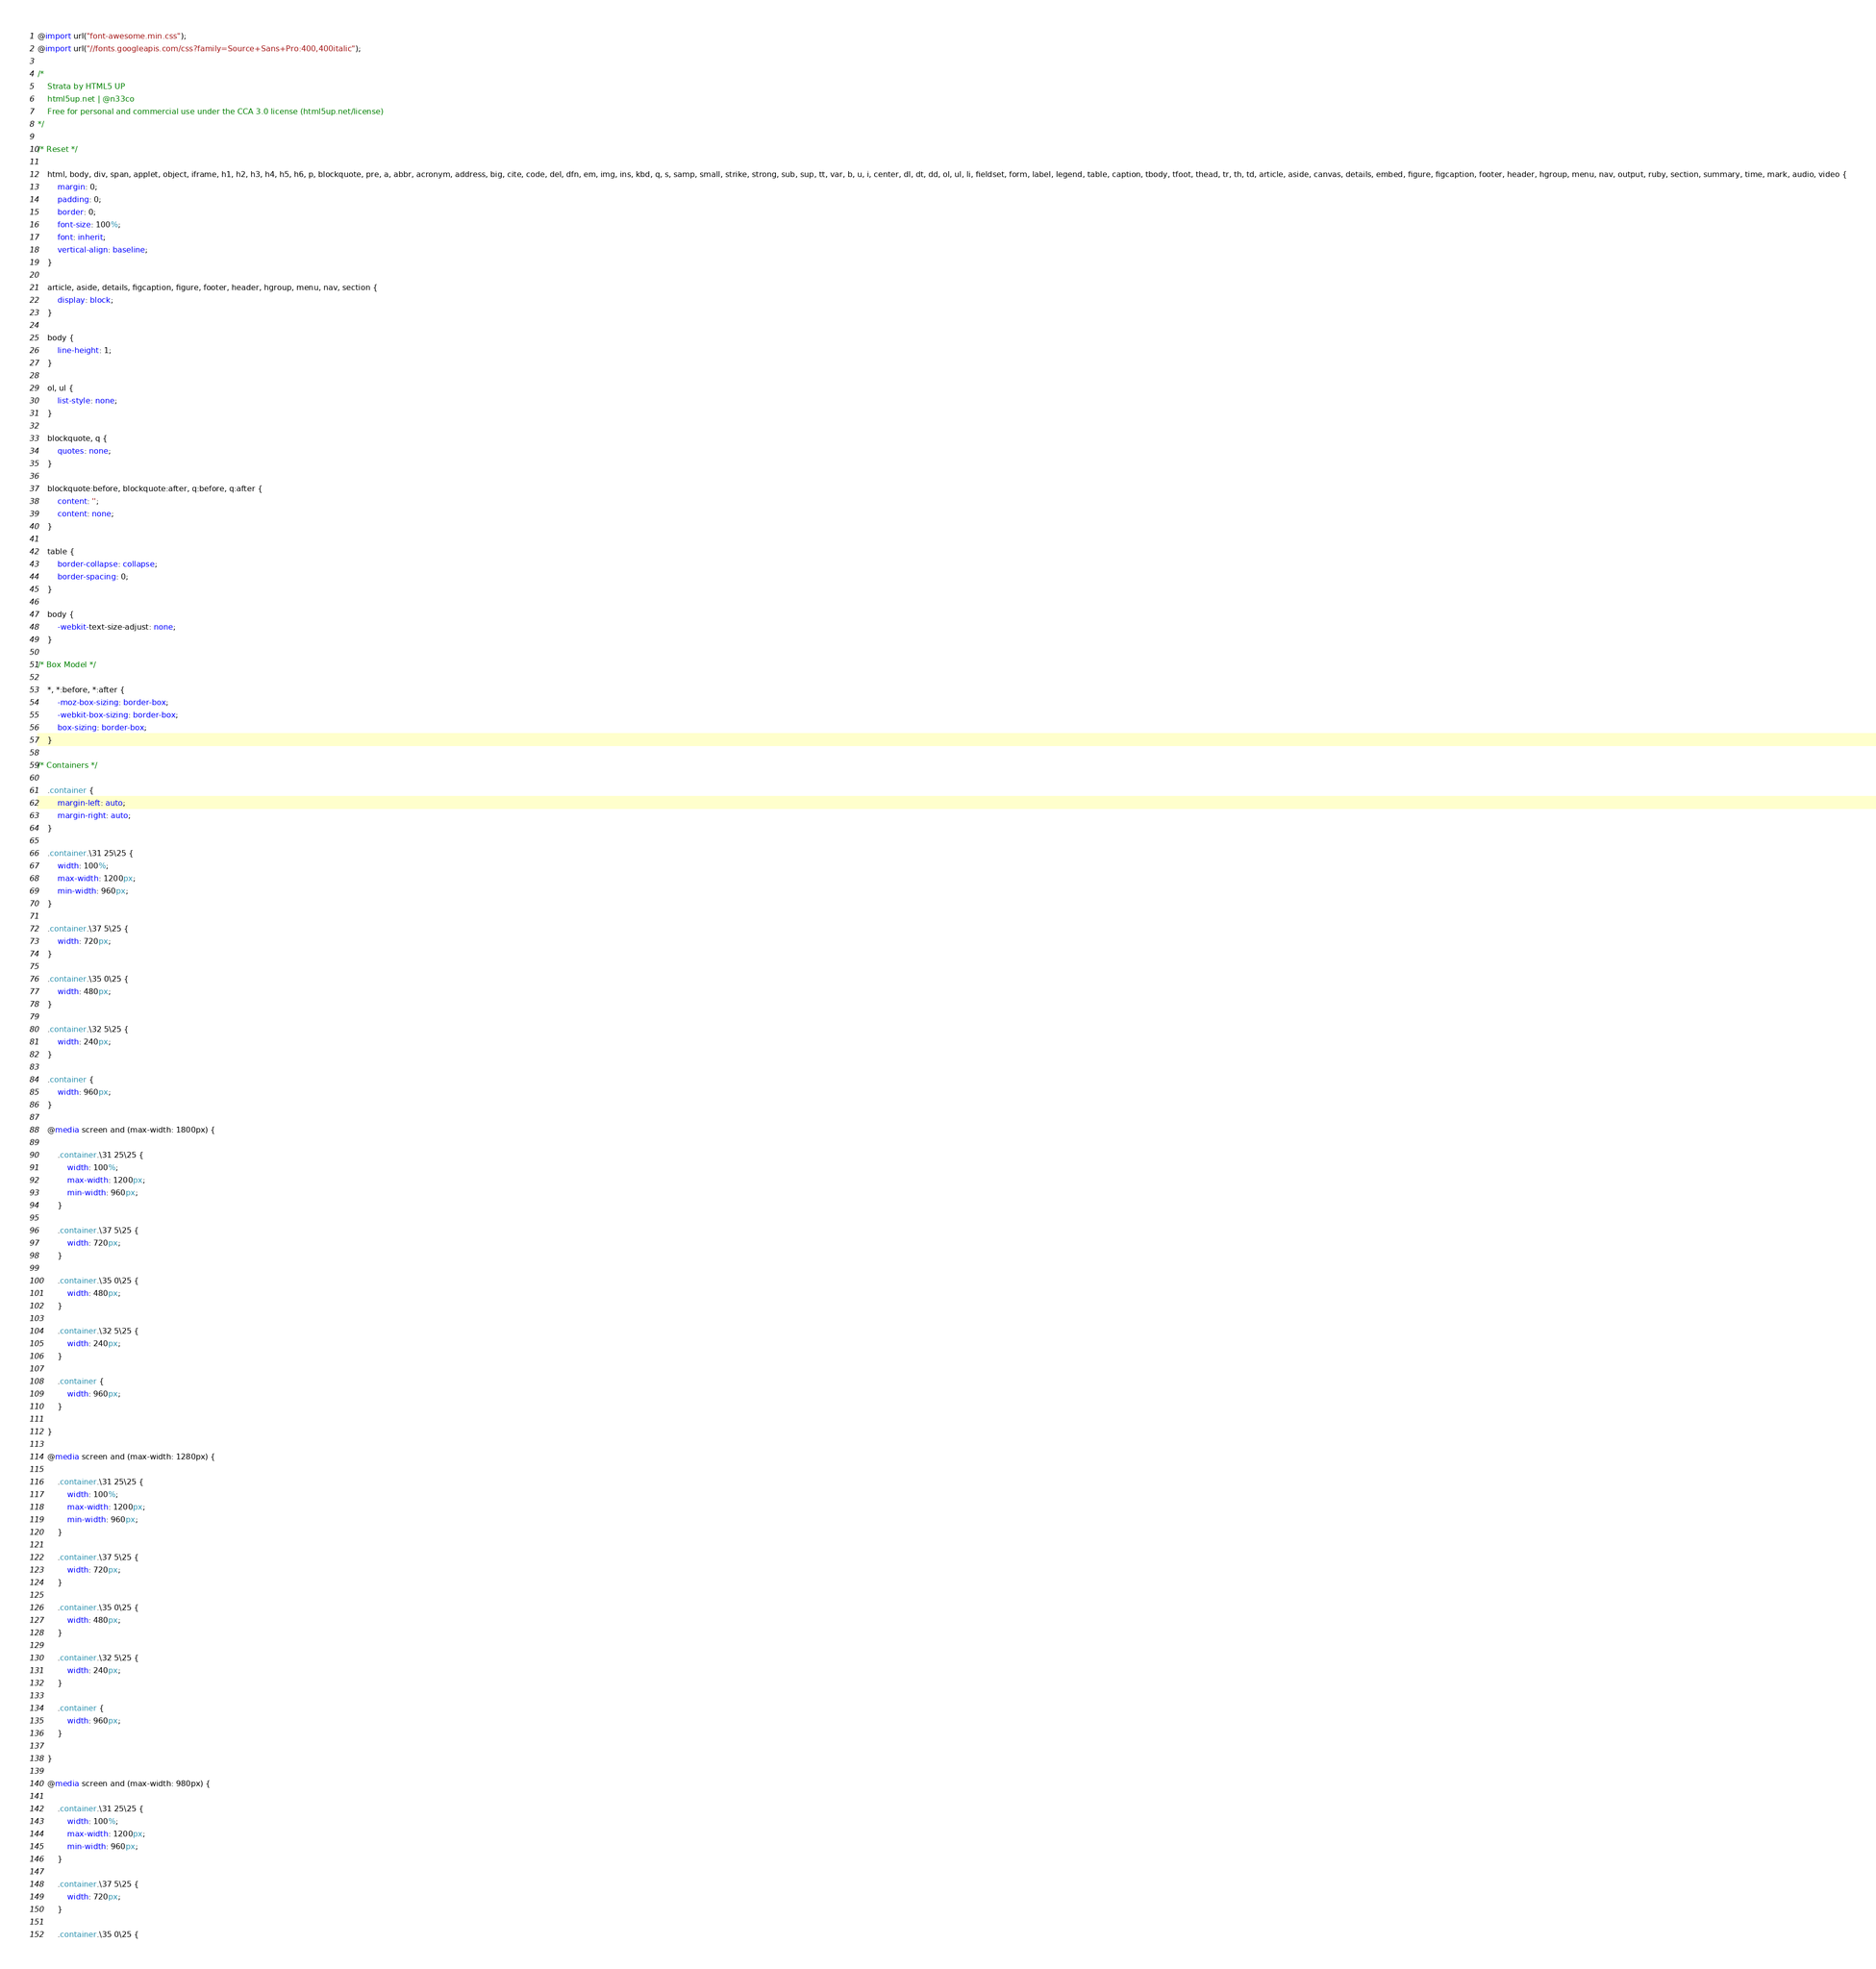<code> <loc_0><loc_0><loc_500><loc_500><_CSS_>@import url("font-awesome.min.css");
@import url("//fonts.googleapis.com/css?family=Source+Sans+Pro:400,400italic");

/*
	Strata by HTML5 UP
	html5up.net | @n33co
	Free for personal and commercial use under the CCA 3.0 license (html5up.net/license)
*/

/* Reset */

	html, body, div, span, applet, object, iframe, h1, h2, h3, h4, h5, h6, p, blockquote, pre, a, abbr, acronym, address, big, cite, code, del, dfn, em, img, ins, kbd, q, s, samp, small, strike, strong, sub, sup, tt, var, b, u, i, center, dl, dt, dd, ol, ul, li, fieldset, form, label, legend, table, caption, tbody, tfoot, thead, tr, th, td, article, aside, canvas, details, embed, figure, figcaption, footer, header, hgroup, menu, nav, output, ruby, section, summary, time, mark, audio, video {
		margin: 0;
		padding: 0;
		border: 0;
		font-size: 100%;
		font: inherit;
		vertical-align: baseline;
	}

	article, aside, details, figcaption, figure, footer, header, hgroup, menu, nav, section {
		display: block;
	}

	body {
		line-height: 1;
	}

	ol, ul {
		list-style: none;
	}

	blockquote, q {
		quotes: none;
	}

	blockquote:before, blockquote:after, q:before, q:after {
		content: '';
		content: none;
	}

	table {
		border-collapse: collapse;
		border-spacing: 0;
	}

	body {
		-webkit-text-size-adjust: none;
	}

/* Box Model */

	*, *:before, *:after {
		-moz-box-sizing: border-box;
		-webkit-box-sizing: border-box;
		box-sizing: border-box;
	}

/* Containers */

	.container {
		margin-left: auto;
		margin-right: auto;
	}

	.container.\31 25\25 {
		width: 100%;
		max-width: 1200px;
		min-width: 960px;
	}

	.container.\37 5\25 {
		width: 720px;
	}

	.container.\35 0\25 {
		width: 480px;
	}

	.container.\32 5\25 {
		width: 240px;
	}

	.container {
		width: 960px;
	}

	@media screen and (max-width: 1800px) {

		.container.\31 25\25 {
			width: 100%;
			max-width: 1200px;
			min-width: 960px;
		}

		.container.\37 5\25 {
			width: 720px;
		}

		.container.\35 0\25 {
			width: 480px;
		}

		.container.\32 5\25 {
			width: 240px;
		}

		.container {
			width: 960px;
		}

	}

	@media screen and (max-width: 1280px) {

		.container.\31 25\25 {
			width: 100%;
			max-width: 1200px;
			min-width: 960px;
		}

		.container.\37 5\25 {
			width: 720px;
		}

		.container.\35 0\25 {
			width: 480px;
		}

		.container.\32 5\25 {
			width: 240px;
		}

		.container {
			width: 960px;
		}

	}

	@media screen and (max-width: 980px) {

		.container.\31 25\25 {
			width: 100%;
			max-width: 1200px;
			min-width: 960px;
		}

		.container.\37 5\25 {
			width: 720px;
		}

		.container.\35 0\25 {</code> 